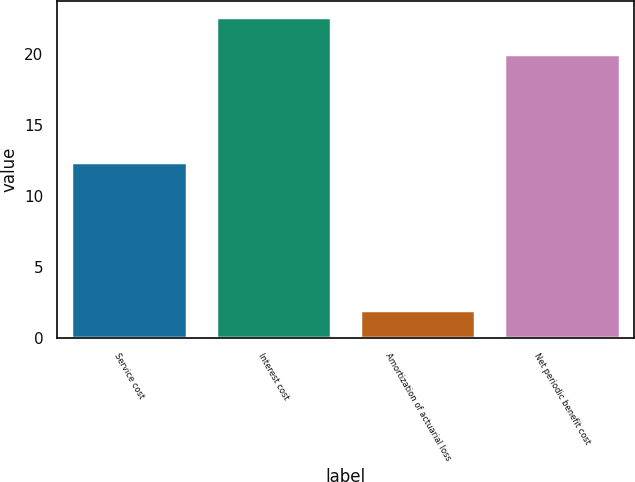Convert chart to OTSL. <chart><loc_0><loc_0><loc_500><loc_500><bar_chart><fcel>Service cost<fcel>Interest cost<fcel>Amortization of actuarial loss<fcel>Net periodic benefit cost<nl><fcel>12.4<fcel>22.6<fcel>2<fcel>20<nl></chart> 